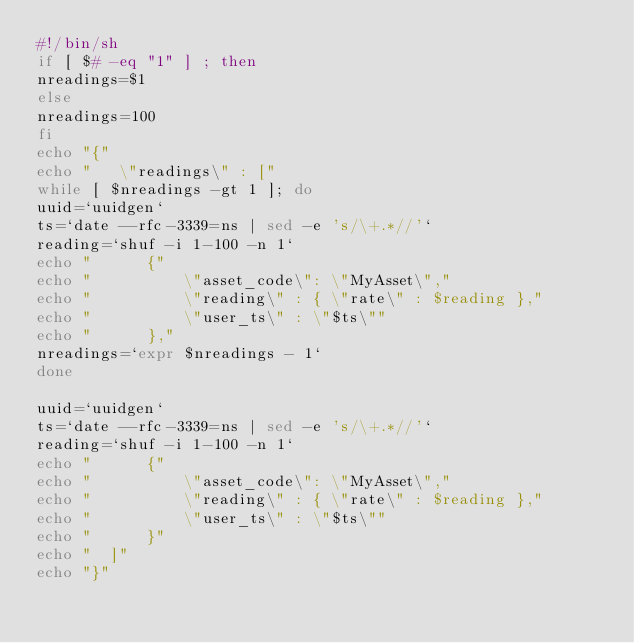Convert code to text. <code><loc_0><loc_0><loc_500><loc_500><_Bash_>#!/bin/sh
if [ $# -eq "1" ] ; then
nreadings=$1
else
nreadings=100
fi
echo "{"
echo "   \"readings\" : ["
while [ $nreadings -gt 1 ]; do
uuid=`uuidgen`
ts=`date --rfc-3339=ns | sed -e 's/\+.*//'`
reading=`shuf -i 1-100 -n 1`
echo "		{"
echo "			\"asset_code\": \"MyAsset\","
echo "			\"reading\" : { \"rate\" : $reading },"
echo "			\"user_ts\" : \"$ts\""
echo "		},"
nreadings=`expr $nreadings - 1`
done

uuid=`uuidgen`
ts=`date --rfc-3339=ns | sed -e 's/\+.*//'`
reading=`shuf -i 1-100 -n 1`
echo "		{"
echo "			\"asset_code\": \"MyAsset\","
echo "			\"reading\" : { \"rate\" : $reading },"
echo "			\"user_ts\" : \"$ts\""
echo "		}"
echo "	]"
echo "}"
</code> 